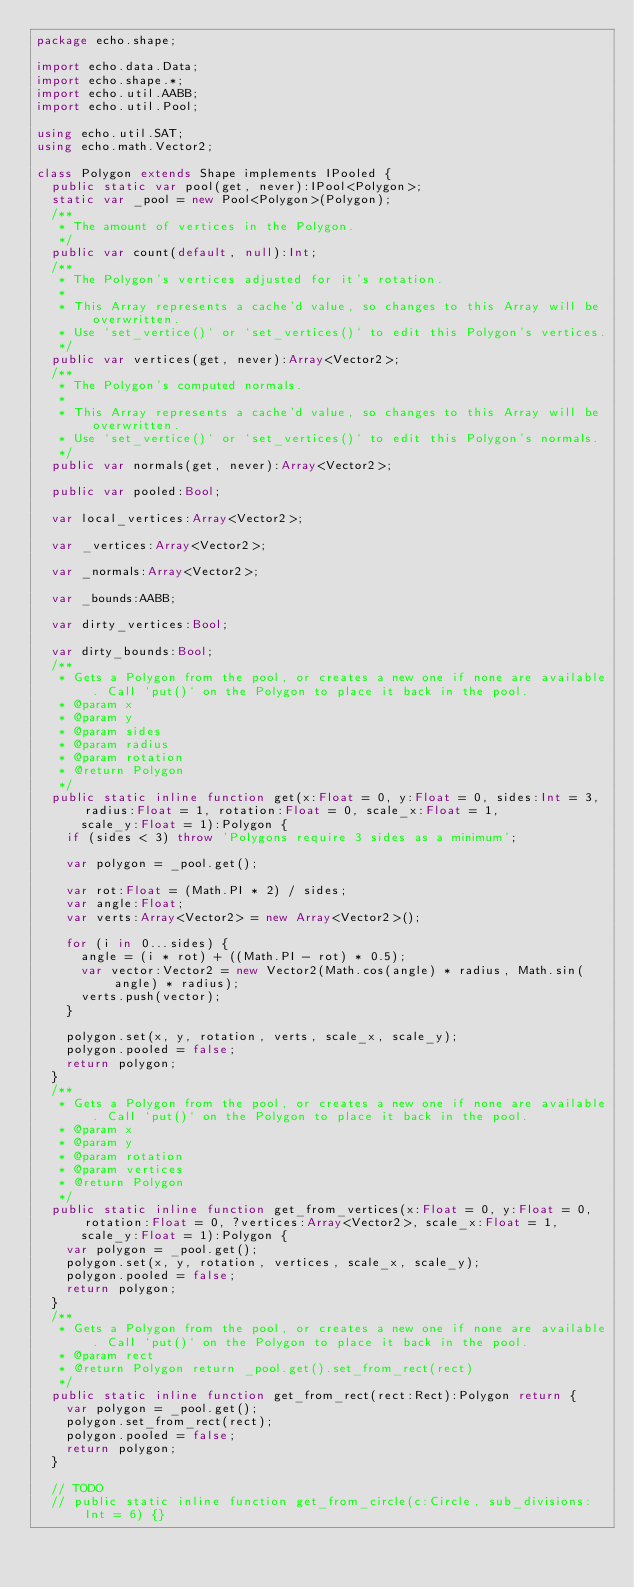Convert code to text. <code><loc_0><loc_0><loc_500><loc_500><_Haxe_>package echo.shape;

import echo.data.Data;
import echo.shape.*;
import echo.util.AABB;
import echo.util.Pool;

using echo.util.SAT;
using echo.math.Vector2;

class Polygon extends Shape implements IPooled {
  public static var pool(get, never):IPool<Polygon>;
  static var _pool = new Pool<Polygon>(Polygon);
  /**
   * The amount of vertices in the Polygon.
   */
  public var count(default, null):Int;
  /**
   * The Polygon's vertices adjusted for it's rotation.
   *
   * This Array represents a cache'd value, so changes to this Array will be overwritten.
   * Use `set_vertice()` or `set_vertices()` to edit this Polygon's vertices.
   */
  public var vertices(get, never):Array<Vector2>;
  /**
   * The Polygon's computed normals.
   *
   * This Array represents a cache'd value, so changes to this Array will be overwritten.
   * Use `set_vertice()` or `set_vertices()` to edit this Polygon's normals.
   */
  public var normals(get, never):Array<Vector2>;

  public var pooled:Bool;

  var local_vertices:Array<Vector2>;

  var _vertices:Array<Vector2>;

  var _normals:Array<Vector2>;

  var _bounds:AABB;

  var dirty_vertices:Bool;

  var dirty_bounds:Bool;
  /**
   * Gets a Polygon from the pool, or creates a new one if none are available. Call `put()` on the Polygon to place it back in the pool.
   * @param x
   * @param y
   * @param sides
   * @param radius
   * @param rotation
   * @return Polygon
   */
  public static inline function get(x:Float = 0, y:Float = 0, sides:Int = 3, radius:Float = 1, rotation:Float = 0, scale_x:Float = 1,
      scale_y:Float = 1):Polygon {
    if (sides < 3) throw 'Polygons require 3 sides as a minimum';

    var polygon = _pool.get();

    var rot:Float = (Math.PI * 2) / sides;
    var angle:Float;
    var verts:Array<Vector2> = new Array<Vector2>();

    for (i in 0...sides) {
      angle = (i * rot) + ((Math.PI - rot) * 0.5);
      var vector:Vector2 = new Vector2(Math.cos(angle) * radius, Math.sin(angle) * radius);
      verts.push(vector);
    }

    polygon.set(x, y, rotation, verts, scale_x, scale_y);
    polygon.pooled = false;
    return polygon;
  }
  /**
   * Gets a Polygon from the pool, or creates a new one if none are available. Call `put()` on the Polygon to place it back in the pool.
   * @param x
   * @param y
   * @param rotation
   * @param vertices
   * @return Polygon
   */
  public static inline function get_from_vertices(x:Float = 0, y:Float = 0, rotation:Float = 0, ?vertices:Array<Vector2>, scale_x:Float = 1,
      scale_y:Float = 1):Polygon {
    var polygon = _pool.get();
    polygon.set(x, y, rotation, vertices, scale_x, scale_y);
    polygon.pooled = false;
    return polygon;
  }
  /**
   * Gets a Polygon from the pool, or creates a new one if none are available. Call `put()` on the Polygon to place it back in the pool.
   * @param rect
   * @return Polygon return _pool.get().set_from_rect(rect)
   */
  public static inline function get_from_rect(rect:Rect):Polygon return {
    var polygon = _pool.get();
    polygon.set_from_rect(rect);
    polygon.pooled = false;
    return polygon;
  }

  // TODO
  // public static inline function get_from_circle(c:Circle, sub_divisions:Int = 6) {}
</code> 